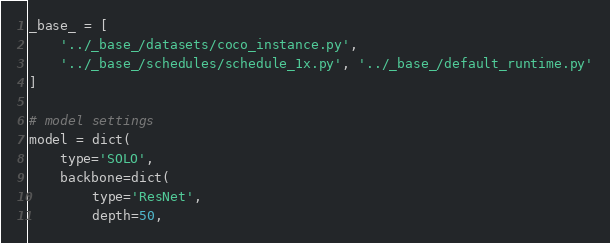<code> <loc_0><loc_0><loc_500><loc_500><_Python_>_base_ = [
    '../_base_/datasets/coco_instance.py',
    '../_base_/schedules/schedule_1x.py', '../_base_/default_runtime.py'
]

# model settings
model = dict(
    type='SOLO',
    backbone=dict(
        type='ResNet',
        depth=50,</code> 